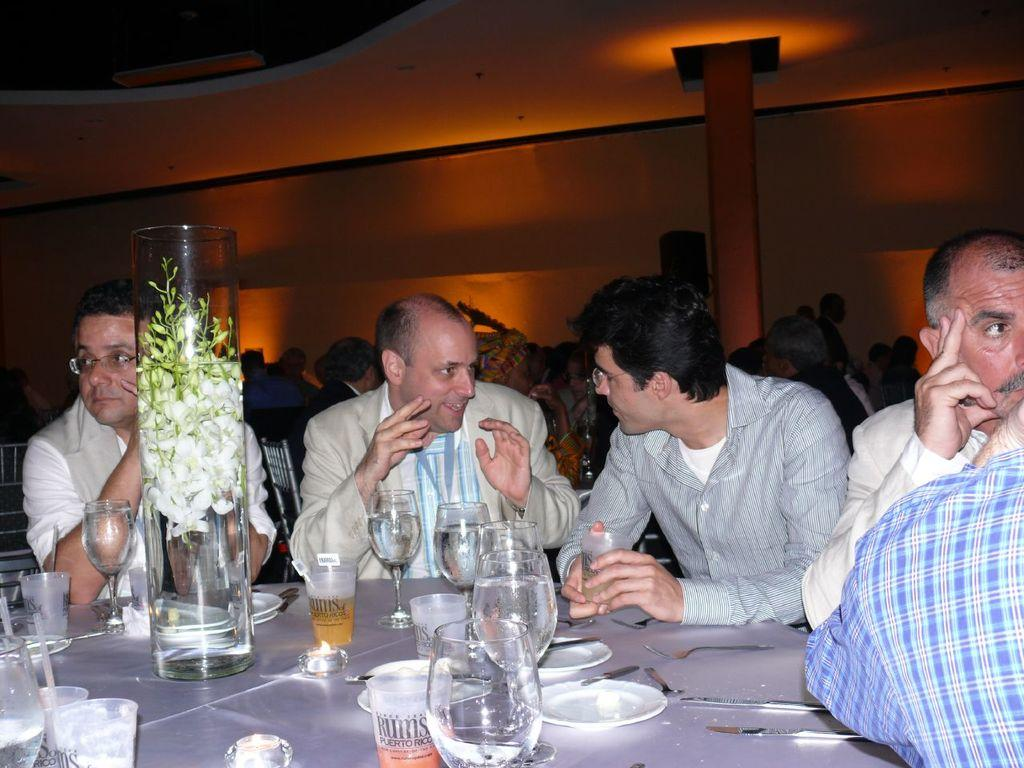What are the people in the image doing? The people in the image are sitting near a table. What objects can be seen on the table? There are glasses, plates, forks, knives, and a flower vase on the table. Are there any other people visible in the image? Yes, there are people in the background of the image. What can be seen in the background of the image? There is a wall in the background of the image. What type of powder is being used by the plantation workers in the image? There are no plantation workers or powder present in the image. How many roads can be seen in the image? There are no roads visible in the image. 